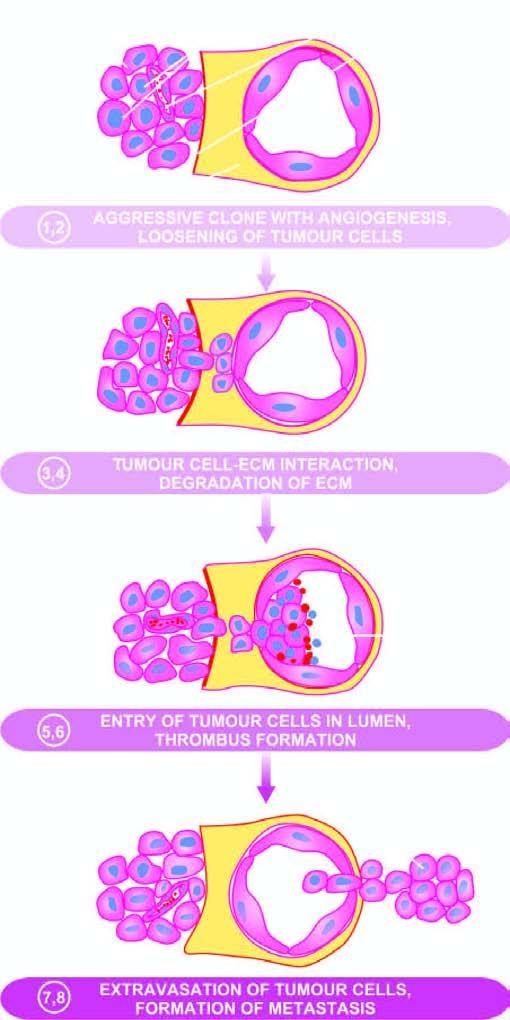do numbers correspond to their description in the text?
Answer the question using a single word or phrase. No 